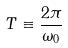Convert formula to latex. <formula><loc_0><loc_0><loc_500><loc_500>T \equiv \frac { 2 \pi } { \omega _ { 0 } }</formula> 